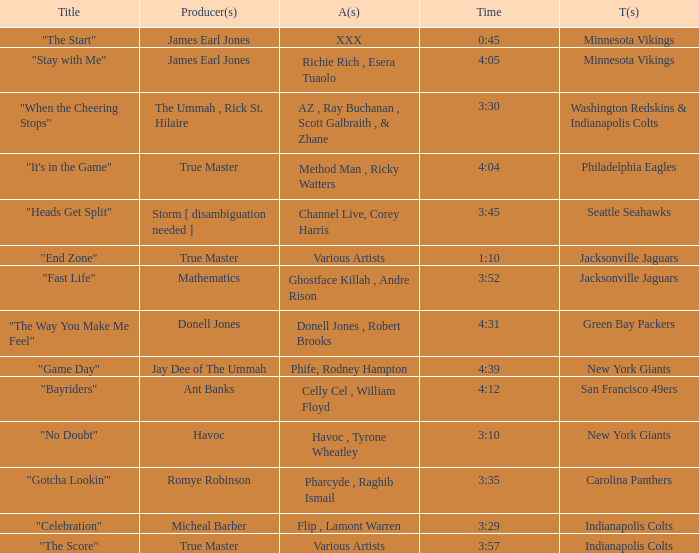Could you help me parse every detail presented in this table? {'header': ['Title', 'Producer(s)', 'A(s)', 'Time', 'T(s)'], 'rows': [['"The Start"', 'James Earl Jones', 'XXX', '0:45', 'Minnesota Vikings'], ['"Stay with Me"', 'James Earl Jones', 'Richie Rich , Esera Tuaolo', '4:05', 'Minnesota Vikings'], ['"When the Cheering Stops"', 'The Ummah , Rick St. Hilaire', 'AZ , Ray Buchanan , Scott Galbraith , & Zhane', '3:30', 'Washington Redskins & Indianapolis Colts'], ['"It\'s in the Game"', 'True Master', 'Method Man , Ricky Watters', '4:04', 'Philadelphia Eagles'], ['"Heads Get Split"', 'Storm [ disambiguation needed ]', 'Channel Live, Corey Harris', '3:45', 'Seattle Seahawks'], ['"End Zone"', 'True Master', 'Various Artists', '1:10', 'Jacksonville Jaguars'], ['"Fast Life"', 'Mathematics', 'Ghostface Killah , Andre Rison', '3:52', 'Jacksonville Jaguars'], ['"The Way You Make Me Feel"', 'Donell Jones', 'Donell Jones , Robert Brooks', '4:31', 'Green Bay Packers'], ['"Game Day"', 'Jay Dee of The Ummah', 'Phife, Rodney Hampton', '4:39', 'New York Giants'], ['"Bayriders"', 'Ant Banks', 'Celly Cel , William Floyd', '4:12', 'San Francisco 49ers'], ['"No Doubt"', 'Havoc', 'Havoc , Tyrone Wheatley', '3:10', 'New York Giants'], ['"Gotcha Lookin\'"', 'Romye Robinson', 'Pharcyde , Raghib Ismail', '3:35', 'Carolina Panthers'], ['"Celebration"', 'Micheal Barber', 'Flip , Lamont Warren', '3:29', 'Indianapolis Colts'], ['"The Score"', 'True Master', 'Various Artists', '3:57', 'Indianapolis Colts']]} What teams used a track 3:29 long? Indianapolis Colts. 